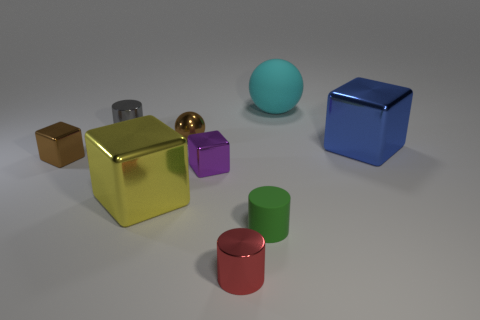What number of objects are either tiny blue metallic blocks or small blocks? 2 